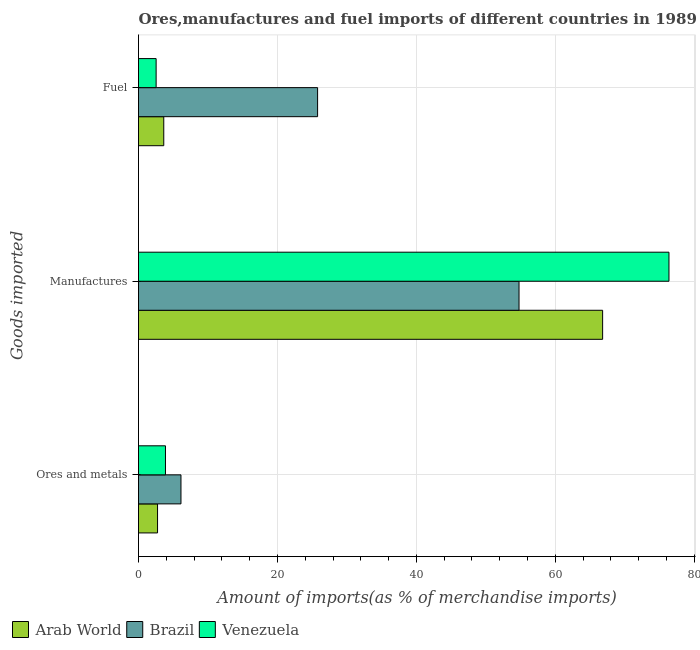How many different coloured bars are there?
Offer a very short reply. 3. Are the number of bars per tick equal to the number of legend labels?
Offer a very short reply. Yes. How many bars are there on the 2nd tick from the top?
Your response must be concise. 3. What is the label of the 3rd group of bars from the top?
Your answer should be very brief. Ores and metals. What is the percentage of fuel imports in Venezuela?
Your answer should be compact. 2.54. Across all countries, what is the maximum percentage of ores and metals imports?
Offer a very short reply. 6.11. Across all countries, what is the minimum percentage of fuel imports?
Provide a succinct answer. 2.54. In which country was the percentage of fuel imports maximum?
Provide a short and direct response. Brazil. What is the total percentage of manufactures imports in the graph?
Your response must be concise. 197.92. What is the difference between the percentage of manufactures imports in Brazil and that in Venezuela?
Offer a terse response. -21.58. What is the difference between the percentage of manufactures imports in Brazil and the percentage of ores and metals imports in Arab World?
Your answer should be very brief. 52.03. What is the average percentage of fuel imports per country?
Provide a succinct answer. 10.65. What is the difference between the percentage of fuel imports and percentage of ores and metals imports in Arab World?
Offer a very short reply. 0.89. What is the ratio of the percentage of ores and metals imports in Brazil to that in Venezuela?
Give a very brief answer. 1.57. Is the difference between the percentage of ores and metals imports in Brazil and Arab World greater than the difference between the percentage of fuel imports in Brazil and Arab World?
Offer a terse response. No. What is the difference between the highest and the second highest percentage of ores and metals imports?
Your answer should be very brief. 2.23. What is the difference between the highest and the lowest percentage of manufactures imports?
Offer a terse response. 21.58. What does the 3rd bar from the top in Fuel represents?
Provide a succinct answer. Arab World. What does the 1st bar from the bottom in Ores and metals represents?
Provide a short and direct response. Arab World. How many countries are there in the graph?
Your answer should be very brief. 3. Are the values on the major ticks of X-axis written in scientific E-notation?
Provide a short and direct response. No. Does the graph contain any zero values?
Provide a succinct answer. No. Does the graph contain grids?
Your response must be concise. Yes. What is the title of the graph?
Give a very brief answer. Ores,manufactures and fuel imports of different countries in 1989. What is the label or title of the X-axis?
Your answer should be very brief. Amount of imports(as % of merchandise imports). What is the label or title of the Y-axis?
Offer a terse response. Goods imported. What is the Amount of imports(as % of merchandise imports) in Arab World in Ores and metals?
Offer a terse response. 2.74. What is the Amount of imports(as % of merchandise imports) of Brazil in Ores and metals?
Offer a very short reply. 6.11. What is the Amount of imports(as % of merchandise imports) of Venezuela in Ores and metals?
Offer a very short reply. 3.88. What is the Amount of imports(as % of merchandise imports) of Arab World in Manufactures?
Provide a short and direct response. 66.8. What is the Amount of imports(as % of merchandise imports) in Brazil in Manufactures?
Keep it short and to the point. 54.77. What is the Amount of imports(as % of merchandise imports) in Venezuela in Manufactures?
Keep it short and to the point. 76.35. What is the Amount of imports(as % of merchandise imports) of Arab World in Fuel?
Your answer should be very brief. 3.64. What is the Amount of imports(as % of merchandise imports) in Brazil in Fuel?
Provide a short and direct response. 25.78. What is the Amount of imports(as % of merchandise imports) in Venezuela in Fuel?
Offer a terse response. 2.54. Across all Goods imported, what is the maximum Amount of imports(as % of merchandise imports) in Arab World?
Your answer should be compact. 66.8. Across all Goods imported, what is the maximum Amount of imports(as % of merchandise imports) of Brazil?
Ensure brevity in your answer.  54.77. Across all Goods imported, what is the maximum Amount of imports(as % of merchandise imports) in Venezuela?
Your response must be concise. 76.35. Across all Goods imported, what is the minimum Amount of imports(as % of merchandise imports) of Arab World?
Ensure brevity in your answer.  2.74. Across all Goods imported, what is the minimum Amount of imports(as % of merchandise imports) of Brazil?
Make the answer very short. 6.11. Across all Goods imported, what is the minimum Amount of imports(as % of merchandise imports) of Venezuela?
Provide a succinct answer. 2.54. What is the total Amount of imports(as % of merchandise imports) of Arab World in the graph?
Keep it short and to the point. 73.18. What is the total Amount of imports(as % of merchandise imports) in Brazil in the graph?
Your response must be concise. 86.66. What is the total Amount of imports(as % of merchandise imports) of Venezuela in the graph?
Provide a short and direct response. 82.77. What is the difference between the Amount of imports(as % of merchandise imports) in Arab World in Ores and metals and that in Manufactures?
Your answer should be very brief. -64.06. What is the difference between the Amount of imports(as % of merchandise imports) of Brazil in Ores and metals and that in Manufactures?
Keep it short and to the point. -48.66. What is the difference between the Amount of imports(as % of merchandise imports) in Venezuela in Ores and metals and that in Manufactures?
Your answer should be compact. -72.47. What is the difference between the Amount of imports(as % of merchandise imports) of Arab World in Ores and metals and that in Fuel?
Offer a very short reply. -0.89. What is the difference between the Amount of imports(as % of merchandise imports) of Brazil in Ores and metals and that in Fuel?
Give a very brief answer. -19.67. What is the difference between the Amount of imports(as % of merchandise imports) of Venezuela in Ores and metals and that in Fuel?
Keep it short and to the point. 1.34. What is the difference between the Amount of imports(as % of merchandise imports) in Arab World in Manufactures and that in Fuel?
Provide a succinct answer. 63.17. What is the difference between the Amount of imports(as % of merchandise imports) in Brazil in Manufactures and that in Fuel?
Make the answer very short. 28.99. What is the difference between the Amount of imports(as % of merchandise imports) of Venezuela in Manufactures and that in Fuel?
Make the answer very short. 73.82. What is the difference between the Amount of imports(as % of merchandise imports) in Arab World in Ores and metals and the Amount of imports(as % of merchandise imports) in Brazil in Manufactures?
Your response must be concise. -52.03. What is the difference between the Amount of imports(as % of merchandise imports) of Arab World in Ores and metals and the Amount of imports(as % of merchandise imports) of Venezuela in Manufactures?
Offer a very short reply. -73.61. What is the difference between the Amount of imports(as % of merchandise imports) of Brazil in Ores and metals and the Amount of imports(as % of merchandise imports) of Venezuela in Manufactures?
Provide a succinct answer. -70.24. What is the difference between the Amount of imports(as % of merchandise imports) of Arab World in Ores and metals and the Amount of imports(as % of merchandise imports) of Brazil in Fuel?
Ensure brevity in your answer.  -23.04. What is the difference between the Amount of imports(as % of merchandise imports) in Arab World in Ores and metals and the Amount of imports(as % of merchandise imports) in Venezuela in Fuel?
Your answer should be very brief. 0.2. What is the difference between the Amount of imports(as % of merchandise imports) in Brazil in Ores and metals and the Amount of imports(as % of merchandise imports) in Venezuela in Fuel?
Provide a succinct answer. 3.57. What is the difference between the Amount of imports(as % of merchandise imports) in Arab World in Manufactures and the Amount of imports(as % of merchandise imports) in Brazil in Fuel?
Provide a succinct answer. 41.02. What is the difference between the Amount of imports(as % of merchandise imports) of Arab World in Manufactures and the Amount of imports(as % of merchandise imports) of Venezuela in Fuel?
Offer a terse response. 64.27. What is the difference between the Amount of imports(as % of merchandise imports) in Brazil in Manufactures and the Amount of imports(as % of merchandise imports) in Venezuela in Fuel?
Provide a short and direct response. 52.23. What is the average Amount of imports(as % of merchandise imports) of Arab World per Goods imported?
Keep it short and to the point. 24.39. What is the average Amount of imports(as % of merchandise imports) in Brazil per Goods imported?
Your response must be concise. 28.89. What is the average Amount of imports(as % of merchandise imports) in Venezuela per Goods imported?
Provide a short and direct response. 27.59. What is the difference between the Amount of imports(as % of merchandise imports) of Arab World and Amount of imports(as % of merchandise imports) of Brazil in Ores and metals?
Provide a succinct answer. -3.37. What is the difference between the Amount of imports(as % of merchandise imports) of Arab World and Amount of imports(as % of merchandise imports) of Venezuela in Ores and metals?
Provide a succinct answer. -1.14. What is the difference between the Amount of imports(as % of merchandise imports) of Brazil and Amount of imports(as % of merchandise imports) of Venezuela in Ores and metals?
Make the answer very short. 2.23. What is the difference between the Amount of imports(as % of merchandise imports) in Arab World and Amount of imports(as % of merchandise imports) in Brazil in Manufactures?
Offer a very short reply. 12.03. What is the difference between the Amount of imports(as % of merchandise imports) of Arab World and Amount of imports(as % of merchandise imports) of Venezuela in Manufactures?
Ensure brevity in your answer.  -9.55. What is the difference between the Amount of imports(as % of merchandise imports) of Brazil and Amount of imports(as % of merchandise imports) of Venezuela in Manufactures?
Ensure brevity in your answer.  -21.58. What is the difference between the Amount of imports(as % of merchandise imports) of Arab World and Amount of imports(as % of merchandise imports) of Brazil in Fuel?
Ensure brevity in your answer.  -22.14. What is the difference between the Amount of imports(as % of merchandise imports) of Arab World and Amount of imports(as % of merchandise imports) of Venezuela in Fuel?
Your answer should be compact. 1.1. What is the difference between the Amount of imports(as % of merchandise imports) in Brazil and Amount of imports(as % of merchandise imports) in Venezuela in Fuel?
Provide a succinct answer. 23.24. What is the ratio of the Amount of imports(as % of merchandise imports) in Arab World in Ores and metals to that in Manufactures?
Offer a terse response. 0.04. What is the ratio of the Amount of imports(as % of merchandise imports) of Brazil in Ores and metals to that in Manufactures?
Offer a very short reply. 0.11. What is the ratio of the Amount of imports(as % of merchandise imports) of Venezuela in Ores and metals to that in Manufactures?
Offer a very short reply. 0.05. What is the ratio of the Amount of imports(as % of merchandise imports) in Arab World in Ores and metals to that in Fuel?
Provide a short and direct response. 0.75. What is the ratio of the Amount of imports(as % of merchandise imports) of Brazil in Ores and metals to that in Fuel?
Offer a terse response. 0.24. What is the ratio of the Amount of imports(as % of merchandise imports) in Venezuela in Ores and metals to that in Fuel?
Your answer should be compact. 1.53. What is the ratio of the Amount of imports(as % of merchandise imports) of Arab World in Manufactures to that in Fuel?
Your answer should be very brief. 18.38. What is the ratio of the Amount of imports(as % of merchandise imports) in Brazil in Manufactures to that in Fuel?
Offer a very short reply. 2.12. What is the ratio of the Amount of imports(as % of merchandise imports) in Venezuela in Manufactures to that in Fuel?
Make the answer very short. 30.1. What is the difference between the highest and the second highest Amount of imports(as % of merchandise imports) of Arab World?
Provide a short and direct response. 63.17. What is the difference between the highest and the second highest Amount of imports(as % of merchandise imports) of Brazil?
Make the answer very short. 28.99. What is the difference between the highest and the second highest Amount of imports(as % of merchandise imports) in Venezuela?
Provide a succinct answer. 72.47. What is the difference between the highest and the lowest Amount of imports(as % of merchandise imports) of Arab World?
Provide a short and direct response. 64.06. What is the difference between the highest and the lowest Amount of imports(as % of merchandise imports) in Brazil?
Provide a succinct answer. 48.66. What is the difference between the highest and the lowest Amount of imports(as % of merchandise imports) in Venezuela?
Provide a short and direct response. 73.82. 